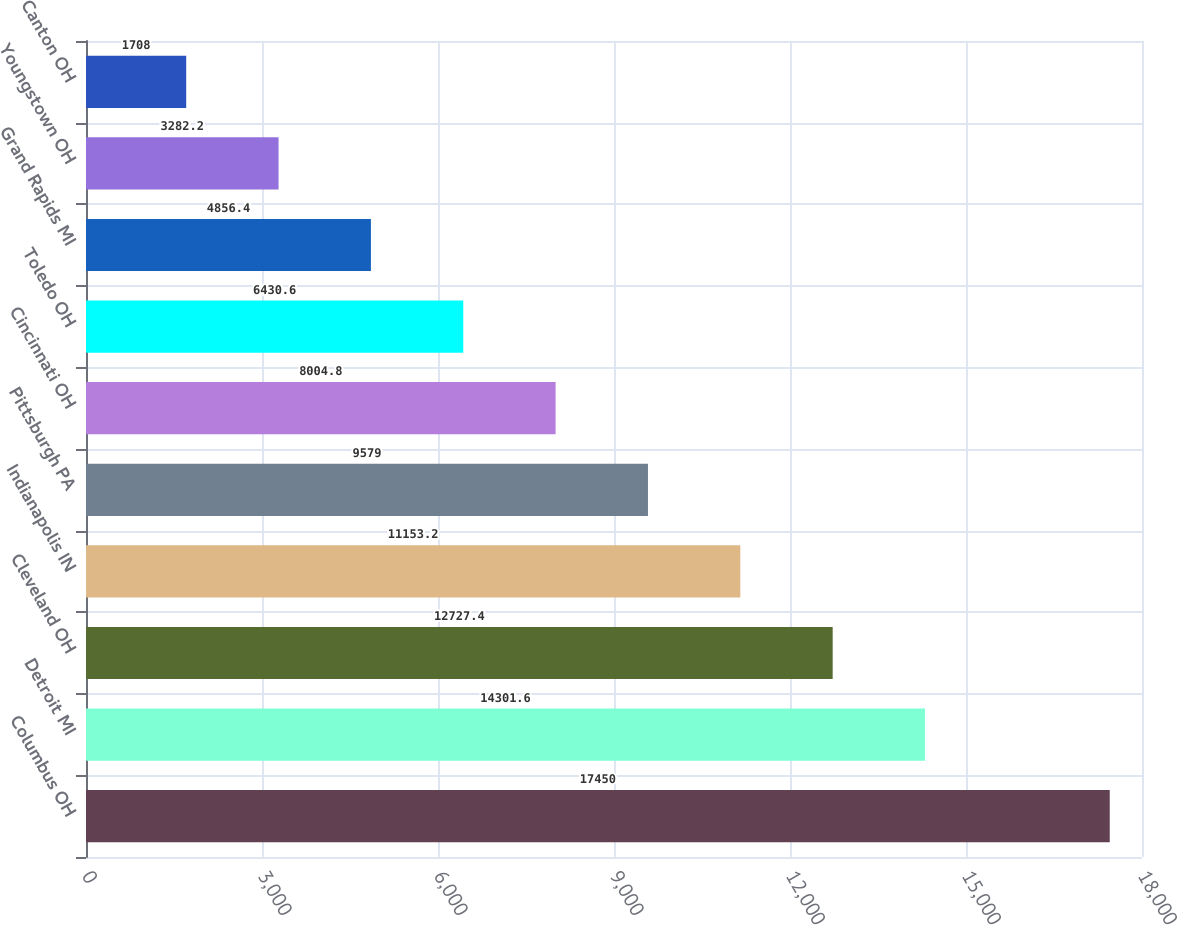Convert chart. <chart><loc_0><loc_0><loc_500><loc_500><bar_chart><fcel>Columbus OH<fcel>Detroit MI<fcel>Cleveland OH<fcel>Indianapolis IN<fcel>Pittsburgh PA<fcel>Cincinnati OH<fcel>Toledo OH<fcel>Grand Rapids MI<fcel>Youngstown OH<fcel>Canton OH<nl><fcel>17450<fcel>14301.6<fcel>12727.4<fcel>11153.2<fcel>9579<fcel>8004.8<fcel>6430.6<fcel>4856.4<fcel>3282.2<fcel>1708<nl></chart> 